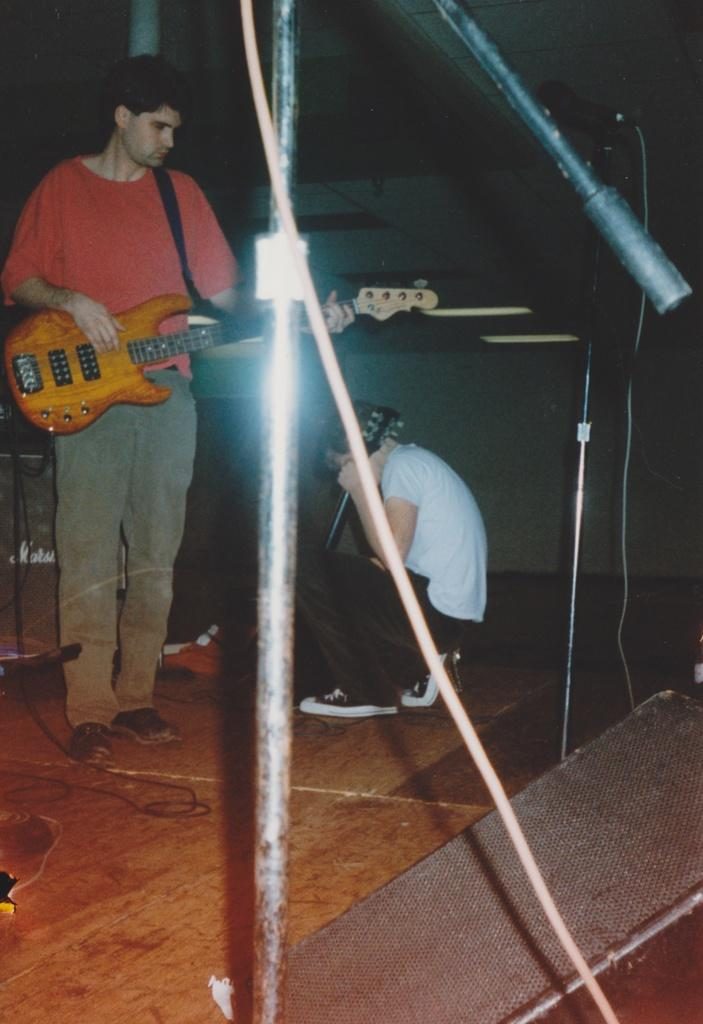What is the main subject of the image? The main subject of the image is a man holding a guitar in the center. Are there any other people in the image? Yes, there is another man sitting and holding a guitar. What can be seen in the background of the image? There is a wall in the background of the image. What word is the man in the image trying to spell with his guitar? There is no indication in the image that the man is trying to spell a word with his guitar. 